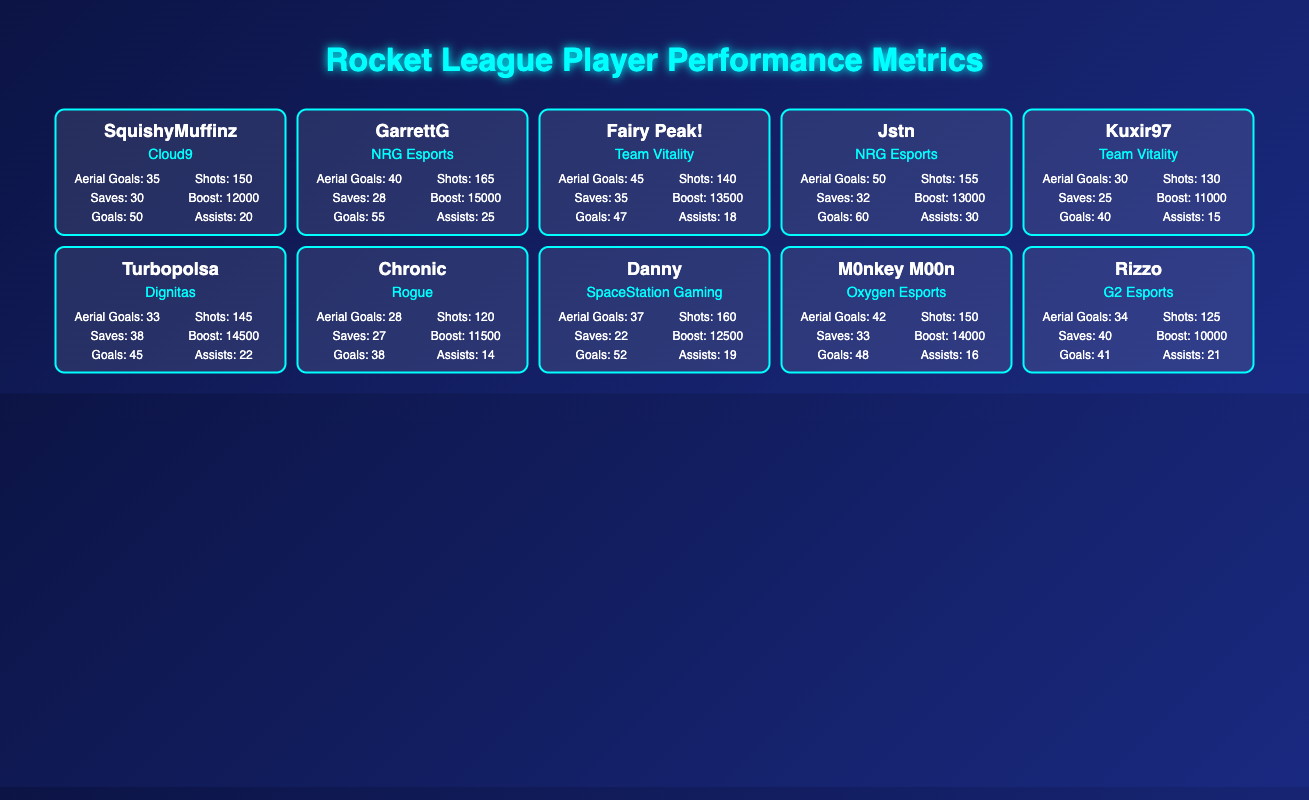What is the total number of Aerial Goals scored by SquishyMuffinz and Jstn? SquishyMuffinz has scored 35 Aerial Goals, and Jstn has scored 50 Aerial Goals. Adding these together: 35 + 50 = 85.
Answer: 85 Which player has the highest number of Boost Used and how much was it? By comparing the Boost Used values for all players, Jstn has the highest with 13000.
Answer: Jstn, 13000 Did GarrettG score more Goals than Fairy Peak!? GarrettG scored 55 Goals while Fairy Peak! scored 47 Goals. Since 55 is greater than 47, the answer is yes.
Answer: Yes What is the average number of Saves for players from Team Vitality? Team Vitality has two players: Fairy Peak! with 35 Saves and Kuxir97 with 25 Saves. To get the average, we sum the Saves: 35 + 25 = 60, and then divide by 2 (the number of players) to get 60/2 = 30.
Answer: 30 Which player has the most Assists among all listed players? Looking through the Assists column, Jstn has the most with 30 Assists.
Answer: Jstn, 30 Who scored the least number of Goals and how many were they? Looking at the Goals column, Chronic has the least with 38 Goals.
Answer: Chronic, 38 How many more Shots on Target did Danny achieve compared to Rizzo? Danny has 160 Shots on Target and Rizzo has 125. The difference is calculated as 160 - 125 = 35.
Answer: 35 Is it true that M0nkey M00n had more Aerial Goals than Turbopolsa? M0nkey M00n scored 42 Aerial Goals, while Turbopolsa scored 33. Since 42 is greater than 33, the answer is yes.
Answer: Yes What is the percentage of Aerial Goals relative to Shots on Target for the player with the lowest percentage? Chronic has 28 Aerial Goals and 120 Shots on Target. The percentage is calculated as (28/120) * 100 = 23.33%. Comparing with others, Chronic has the lowest Aerial Goals percentage.
Answer: 23.33% 